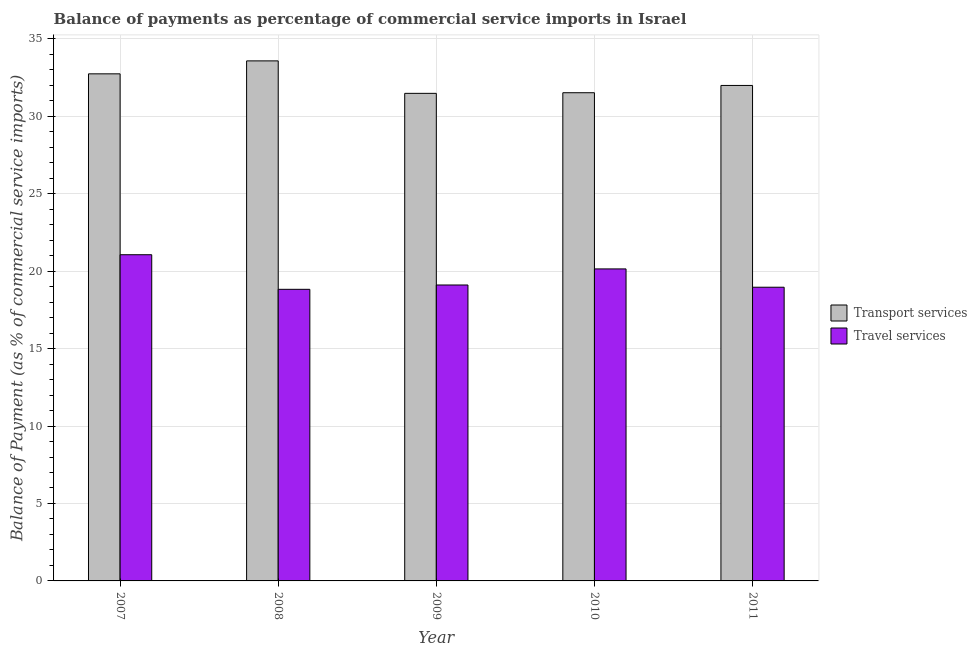How many different coloured bars are there?
Provide a short and direct response. 2. How many groups of bars are there?
Ensure brevity in your answer.  5. Are the number of bars per tick equal to the number of legend labels?
Ensure brevity in your answer.  Yes. Are the number of bars on each tick of the X-axis equal?
Your response must be concise. Yes. What is the label of the 5th group of bars from the left?
Offer a very short reply. 2011. What is the balance of payments of travel services in 2010?
Keep it short and to the point. 20.14. Across all years, what is the maximum balance of payments of transport services?
Give a very brief answer. 33.58. Across all years, what is the minimum balance of payments of travel services?
Provide a short and direct response. 18.83. In which year was the balance of payments of travel services maximum?
Your response must be concise. 2007. In which year was the balance of payments of travel services minimum?
Your response must be concise. 2008. What is the total balance of payments of transport services in the graph?
Offer a very short reply. 161.31. What is the difference between the balance of payments of travel services in 2009 and that in 2010?
Your answer should be very brief. -1.04. What is the difference between the balance of payments of transport services in 2011 and the balance of payments of travel services in 2010?
Provide a succinct answer. 0.47. What is the average balance of payments of travel services per year?
Keep it short and to the point. 19.62. In the year 2010, what is the difference between the balance of payments of travel services and balance of payments of transport services?
Ensure brevity in your answer.  0. What is the ratio of the balance of payments of travel services in 2007 to that in 2009?
Your answer should be very brief. 1.1. What is the difference between the highest and the second highest balance of payments of travel services?
Provide a short and direct response. 0.92. What is the difference between the highest and the lowest balance of payments of travel services?
Your answer should be compact. 2.23. Is the sum of the balance of payments of transport services in 2007 and 2010 greater than the maximum balance of payments of travel services across all years?
Give a very brief answer. Yes. What does the 1st bar from the left in 2008 represents?
Your response must be concise. Transport services. What does the 2nd bar from the right in 2010 represents?
Keep it short and to the point. Transport services. How many bars are there?
Keep it short and to the point. 10. Are all the bars in the graph horizontal?
Your answer should be compact. No. What is the difference between two consecutive major ticks on the Y-axis?
Offer a very short reply. 5. Does the graph contain any zero values?
Give a very brief answer. No. How many legend labels are there?
Give a very brief answer. 2. What is the title of the graph?
Provide a succinct answer. Balance of payments as percentage of commercial service imports in Israel. What is the label or title of the X-axis?
Offer a very short reply. Year. What is the label or title of the Y-axis?
Your answer should be compact. Balance of Payment (as % of commercial service imports). What is the Balance of Payment (as % of commercial service imports) in Transport services in 2007?
Your answer should be very brief. 32.74. What is the Balance of Payment (as % of commercial service imports) of Travel services in 2007?
Offer a terse response. 21.06. What is the Balance of Payment (as % of commercial service imports) of Transport services in 2008?
Offer a terse response. 33.58. What is the Balance of Payment (as % of commercial service imports) in Travel services in 2008?
Give a very brief answer. 18.83. What is the Balance of Payment (as % of commercial service imports) of Transport services in 2009?
Provide a succinct answer. 31.48. What is the Balance of Payment (as % of commercial service imports) of Travel services in 2009?
Offer a terse response. 19.11. What is the Balance of Payment (as % of commercial service imports) of Transport services in 2010?
Offer a very short reply. 31.52. What is the Balance of Payment (as % of commercial service imports) of Travel services in 2010?
Your answer should be very brief. 20.14. What is the Balance of Payment (as % of commercial service imports) in Transport services in 2011?
Make the answer very short. 31.99. What is the Balance of Payment (as % of commercial service imports) of Travel services in 2011?
Your answer should be very brief. 18.96. Across all years, what is the maximum Balance of Payment (as % of commercial service imports) in Transport services?
Offer a very short reply. 33.58. Across all years, what is the maximum Balance of Payment (as % of commercial service imports) of Travel services?
Offer a terse response. 21.06. Across all years, what is the minimum Balance of Payment (as % of commercial service imports) of Transport services?
Offer a very short reply. 31.48. Across all years, what is the minimum Balance of Payment (as % of commercial service imports) of Travel services?
Ensure brevity in your answer.  18.83. What is the total Balance of Payment (as % of commercial service imports) of Transport services in the graph?
Your answer should be very brief. 161.31. What is the total Balance of Payment (as % of commercial service imports) in Travel services in the graph?
Offer a terse response. 98.1. What is the difference between the Balance of Payment (as % of commercial service imports) in Transport services in 2007 and that in 2008?
Provide a succinct answer. -0.84. What is the difference between the Balance of Payment (as % of commercial service imports) in Travel services in 2007 and that in 2008?
Ensure brevity in your answer.  2.23. What is the difference between the Balance of Payment (as % of commercial service imports) of Transport services in 2007 and that in 2009?
Provide a succinct answer. 1.26. What is the difference between the Balance of Payment (as % of commercial service imports) of Travel services in 2007 and that in 2009?
Provide a succinct answer. 1.95. What is the difference between the Balance of Payment (as % of commercial service imports) of Transport services in 2007 and that in 2010?
Offer a terse response. 1.22. What is the difference between the Balance of Payment (as % of commercial service imports) of Travel services in 2007 and that in 2010?
Offer a terse response. 0.92. What is the difference between the Balance of Payment (as % of commercial service imports) in Transport services in 2007 and that in 2011?
Provide a succinct answer. 0.75. What is the difference between the Balance of Payment (as % of commercial service imports) of Travel services in 2007 and that in 2011?
Offer a terse response. 2.1. What is the difference between the Balance of Payment (as % of commercial service imports) of Transport services in 2008 and that in 2009?
Your answer should be compact. 2.1. What is the difference between the Balance of Payment (as % of commercial service imports) in Travel services in 2008 and that in 2009?
Your answer should be compact. -0.28. What is the difference between the Balance of Payment (as % of commercial service imports) in Transport services in 2008 and that in 2010?
Your response must be concise. 2.06. What is the difference between the Balance of Payment (as % of commercial service imports) in Travel services in 2008 and that in 2010?
Make the answer very short. -1.32. What is the difference between the Balance of Payment (as % of commercial service imports) of Transport services in 2008 and that in 2011?
Your response must be concise. 1.59. What is the difference between the Balance of Payment (as % of commercial service imports) of Travel services in 2008 and that in 2011?
Make the answer very short. -0.14. What is the difference between the Balance of Payment (as % of commercial service imports) of Transport services in 2009 and that in 2010?
Make the answer very short. -0.04. What is the difference between the Balance of Payment (as % of commercial service imports) of Travel services in 2009 and that in 2010?
Offer a terse response. -1.04. What is the difference between the Balance of Payment (as % of commercial service imports) in Transport services in 2009 and that in 2011?
Ensure brevity in your answer.  -0.51. What is the difference between the Balance of Payment (as % of commercial service imports) in Travel services in 2009 and that in 2011?
Your response must be concise. 0.14. What is the difference between the Balance of Payment (as % of commercial service imports) in Transport services in 2010 and that in 2011?
Your answer should be compact. -0.47. What is the difference between the Balance of Payment (as % of commercial service imports) in Travel services in 2010 and that in 2011?
Keep it short and to the point. 1.18. What is the difference between the Balance of Payment (as % of commercial service imports) of Transport services in 2007 and the Balance of Payment (as % of commercial service imports) of Travel services in 2008?
Keep it short and to the point. 13.91. What is the difference between the Balance of Payment (as % of commercial service imports) of Transport services in 2007 and the Balance of Payment (as % of commercial service imports) of Travel services in 2009?
Ensure brevity in your answer.  13.63. What is the difference between the Balance of Payment (as % of commercial service imports) in Transport services in 2007 and the Balance of Payment (as % of commercial service imports) in Travel services in 2010?
Make the answer very short. 12.59. What is the difference between the Balance of Payment (as % of commercial service imports) in Transport services in 2007 and the Balance of Payment (as % of commercial service imports) in Travel services in 2011?
Ensure brevity in your answer.  13.78. What is the difference between the Balance of Payment (as % of commercial service imports) in Transport services in 2008 and the Balance of Payment (as % of commercial service imports) in Travel services in 2009?
Keep it short and to the point. 14.47. What is the difference between the Balance of Payment (as % of commercial service imports) in Transport services in 2008 and the Balance of Payment (as % of commercial service imports) in Travel services in 2010?
Make the answer very short. 13.43. What is the difference between the Balance of Payment (as % of commercial service imports) in Transport services in 2008 and the Balance of Payment (as % of commercial service imports) in Travel services in 2011?
Your answer should be very brief. 14.61. What is the difference between the Balance of Payment (as % of commercial service imports) of Transport services in 2009 and the Balance of Payment (as % of commercial service imports) of Travel services in 2010?
Provide a short and direct response. 11.33. What is the difference between the Balance of Payment (as % of commercial service imports) in Transport services in 2009 and the Balance of Payment (as % of commercial service imports) in Travel services in 2011?
Your answer should be very brief. 12.52. What is the difference between the Balance of Payment (as % of commercial service imports) of Transport services in 2010 and the Balance of Payment (as % of commercial service imports) of Travel services in 2011?
Keep it short and to the point. 12.56. What is the average Balance of Payment (as % of commercial service imports) of Transport services per year?
Ensure brevity in your answer.  32.26. What is the average Balance of Payment (as % of commercial service imports) in Travel services per year?
Your answer should be very brief. 19.62. In the year 2007, what is the difference between the Balance of Payment (as % of commercial service imports) of Transport services and Balance of Payment (as % of commercial service imports) of Travel services?
Your answer should be very brief. 11.68. In the year 2008, what is the difference between the Balance of Payment (as % of commercial service imports) in Transport services and Balance of Payment (as % of commercial service imports) in Travel services?
Make the answer very short. 14.75. In the year 2009, what is the difference between the Balance of Payment (as % of commercial service imports) in Transport services and Balance of Payment (as % of commercial service imports) in Travel services?
Your answer should be very brief. 12.37. In the year 2010, what is the difference between the Balance of Payment (as % of commercial service imports) in Transport services and Balance of Payment (as % of commercial service imports) in Travel services?
Provide a succinct answer. 11.38. In the year 2011, what is the difference between the Balance of Payment (as % of commercial service imports) of Transport services and Balance of Payment (as % of commercial service imports) of Travel services?
Offer a terse response. 13.03. What is the ratio of the Balance of Payment (as % of commercial service imports) in Transport services in 2007 to that in 2008?
Give a very brief answer. 0.98. What is the ratio of the Balance of Payment (as % of commercial service imports) of Travel services in 2007 to that in 2008?
Make the answer very short. 1.12. What is the ratio of the Balance of Payment (as % of commercial service imports) of Transport services in 2007 to that in 2009?
Offer a very short reply. 1.04. What is the ratio of the Balance of Payment (as % of commercial service imports) in Travel services in 2007 to that in 2009?
Offer a terse response. 1.1. What is the ratio of the Balance of Payment (as % of commercial service imports) of Transport services in 2007 to that in 2010?
Your answer should be very brief. 1.04. What is the ratio of the Balance of Payment (as % of commercial service imports) of Travel services in 2007 to that in 2010?
Offer a terse response. 1.05. What is the ratio of the Balance of Payment (as % of commercial service imports) in Transport services in 2007 to that in 2011?
Your answer should be very brief. 1.02. What is the ratio of the Balance of Payment (as % of commercial service imports) of Travel services in 2007 to that in 2011?
Make the answer very short. 1.11. What is the ratio of the Balance of Payment (as % of commercial service imports) of Transport services in 2008 to that in 2009?
Offer a very short reply. 1.07. What is the ratio of the Balance of Payment (as % of commercial service imports) of Travel services in 2008 to that in 2009?
Your answer should be compact. 0.99. What is the ratio of the Balance of Payment (as % of commercial service imports) of Transport services in 2008 to that in 2010?
Provide a short and direct response. 1.07. What is the ratio of the Balance of Payment (as % of commercial service imports) in Travel services in 2008 to that in 2010?
Ensure brevity in your answer.  0.93. What is the ratio of the Balance of Payment (as % of commercial service imports) in Transport services in 2008 to that in 2011?
Give a very brief answer. 1.05. What is the ratio of the Balance of Payment (as % of commercial service imports) of Travel services in 2008 to that in 2011?
Offer a terse response. 0.99. What is the ratio of the Balance of Payment (as % of commercial service imports) in Travel services in 2009 to that in 2010?
Your answer should be compact. 0.95. What is the ratio of the Balance of Payment (as % of commercial service imports) in Travel services in 2009 to that in 2011?
Ensure brevity in your answer.  1.01. What is the ratio of the Balance of Payment (as % of commercial service imports) in Transport services in 2010 to that in 2011?
Offer a terse response. 0.99. What is the ratio of the Balance of Payment (as % of commercial service imports) of Travel services in 2010 to that in 2011?
Your answer should be very brief. 1.06. What is the difference between the highest and the second highest Balance of Payment (as % of commercial service imports) of Transport services?
Ensure brevity in your answer.  0.84. What is the difference between the highest and the second highest Balance of Payment (as % of commercial service imports) of Travel services?
Provide a short and direct response. 0.92. What is the difference between the highest and the lowest Balance of Payment (as % of commercial service imports) in Transport services?
Keep it short and to the point. 2.1. What is the difference between the highest and the lowest Balance of Payment (as % of commercial service imports) of Travel services?
Give a very brief answer. 2.23. 